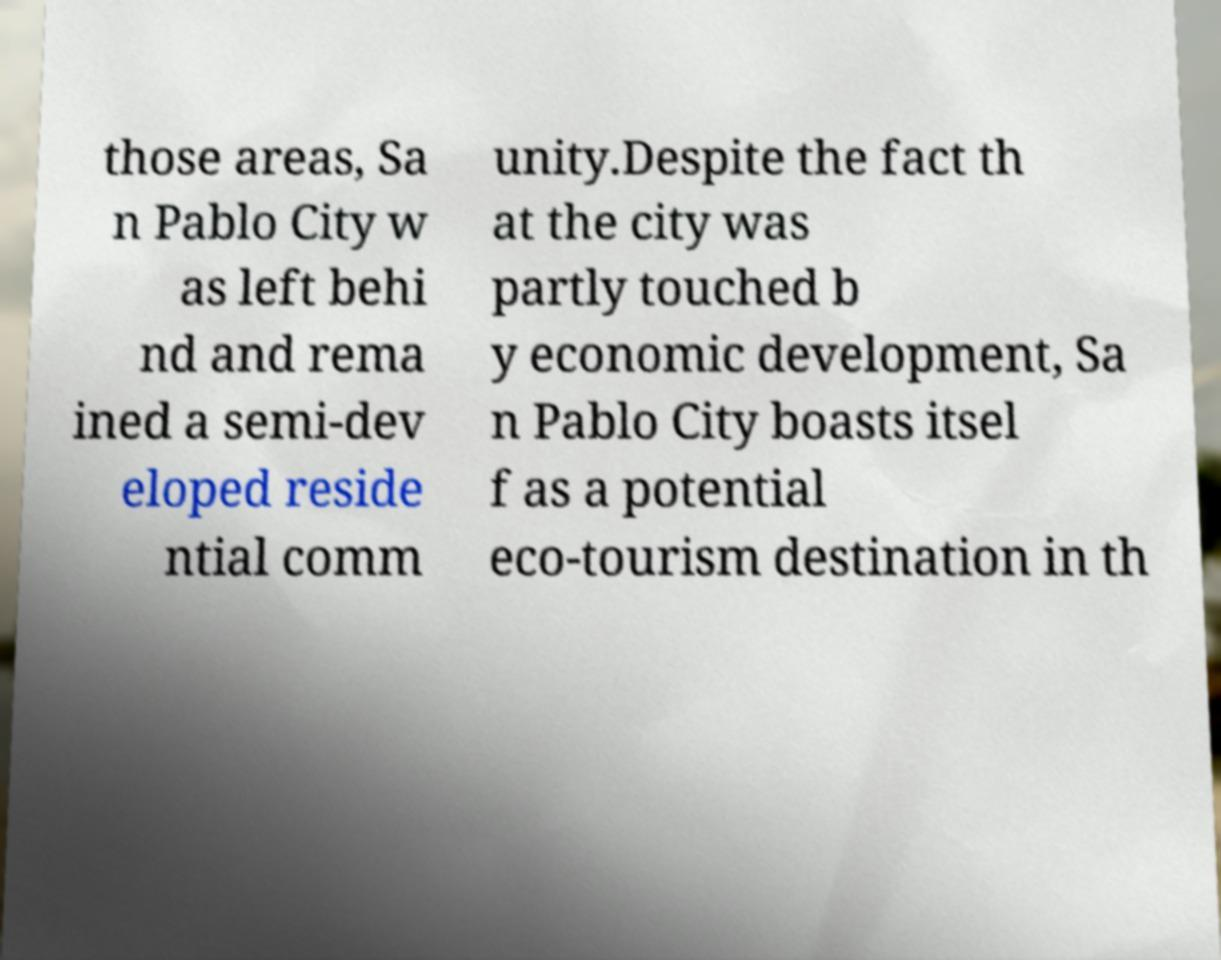Can you read and provide the text displayed in the image?This photo seems to have some interesting text. Can you extract and type it out for me? those areas, Sa n Pablo City w as left behi nd and rema ined a semi-dev eloped reside ntial comm unity.Despite the fact th at the city was partly touched b y economic development, Sa n Pablo City boasts itsel f as a potential eco-tourism destination in th 